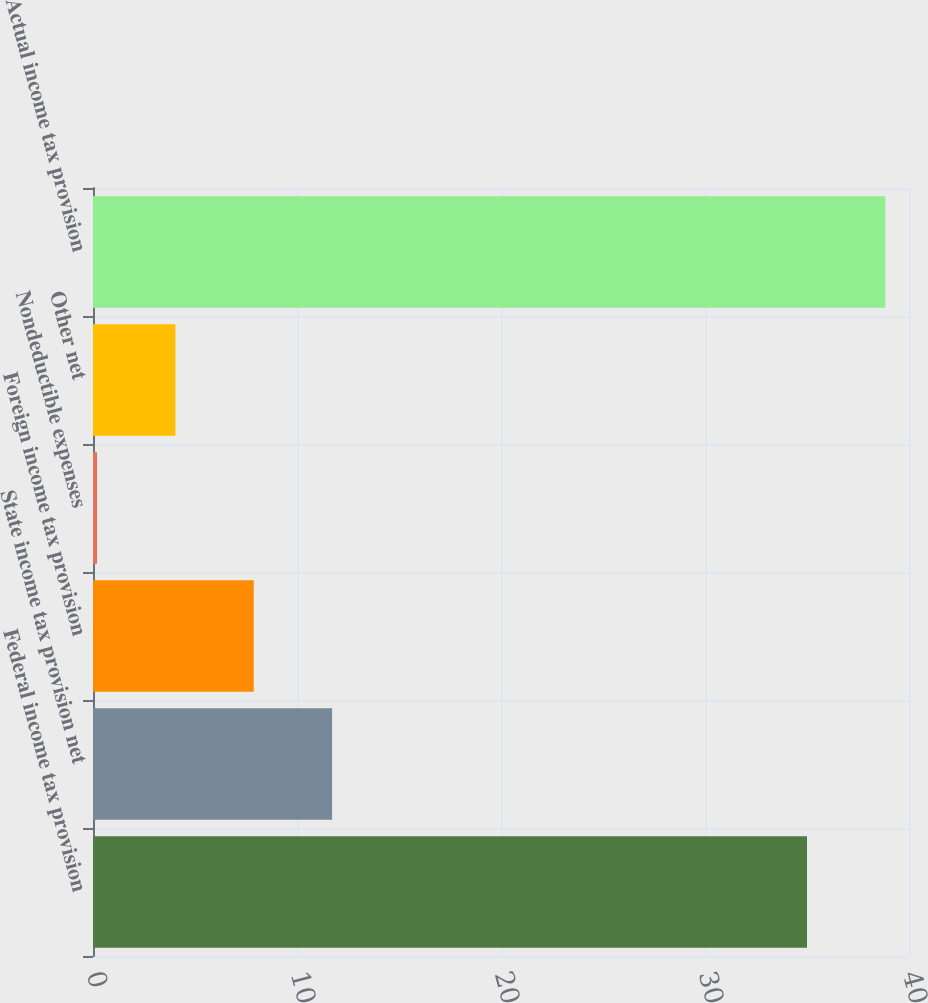Convert chart to OTSL. <chart><loc_0><loc_0><loc_500><loc_500><bar_chart><fcel>Federal income tax provision<fcel>State income tax provision net<fcel>Foreign income tax provision<fcel>Nondeductible expenses<fcel>Other net<fcel>Actual income tax provision<nl><fcel>35<fcel>11.72<fcel>7.88<fcel>0.2<fcel>4.04<fcel>38.84<nl></chart> 